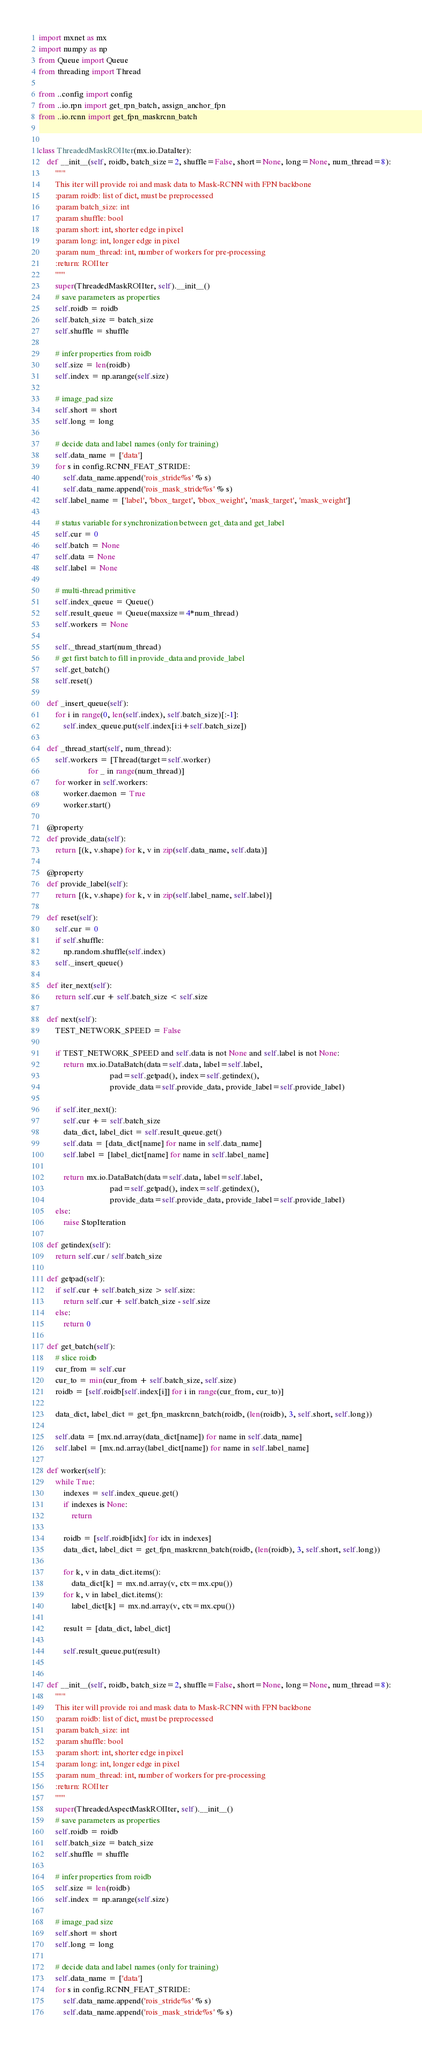Convert code to text. <code><loc_0><loc_0><loc_500><loc_500><_Python_>import mxnet as mx
import numpy as np
from Queue import Queue
from threading import Thread

from ..config import config
from ..io.rpn import get_rpn_batch, assign_anchor_fpn
from ..io.rcnn import get_fpn_maskrcnn_batch


class ThreadedMaskROIIter(mx.io.DataIter):
    def __init__(self, roidb, batch_size=2, shuffle=False, short=None, long=None, num_thread=8):
        """
        This iter will provide roi and mask data to Mask-RCNN with FPN backbone
        :param roidb: list of dict, must be preprocessed
        :param batch_size: int
        :param shuffle: bool
        :param short: int, shorter edge in pixel
        :param long: int, longer edge in pixel
        :param num_thread: int, number of workers for pre-processing
        :return: ROIIter
        """
        super(ThreadedMaskROIIter, self).__init__()
        # save parameters as properties
        self.roidb = roidb
        self.batch_size = batch_size
        self.shuffle = shuffle

        # infer properties from roidb
        self.size = len(roidb)
        self.index = np.arange(self.size)

        # image_pad size
        self.short = short
        self.long = long

        # decide data and label names (only for training)
        self.data_name = ['data']
        for s in config.RCNN_FEAT_STRIDE:
            self.data_name.append('rois_stride%s' % s)
            self.data_name.append('rois_mask_stride%s' % s)
        self.label_name = ['label', 'bbox_target', 'bbox_weight', 'mask_target', 'mask_weight']

        # status variable for synchronization between get_data and get_label
        self.cur = 0
        self.batch = None
        self.data = None
        self.label = None

        # multi-thread primitive
        self.index_queue = Queue()
        self.result_queue = Queue(maxsize=4*num_thread)
        self.workers = None

        self._thread_start(num_thread)
        # get first batch to fill in provide_data and provide_label
        self.get_batch()
        self.reset()

    def _insert_queue(self):
        for i in range(0, len(self.index), self.batch_size)[:-1]:
            self.index_queue.put(self.index[i:i+self.batch_size])

    def _thread_start(self, num_thread):
        self.workers = [Thread(target=self.worker)
                        for _ in range(num_thread)]
        for worker in self.workers:
            worker.daemon = True
            worker.start()

    @property
    def provide_data(self):
        return [(k, v.shape) for k, v in zip(self.data_name, self.data)]

    @property
    def provide_label(self):
        return [(k, v.shape) for k, v in zip(self.label_name, self.label)]

    def reset(self):
        self.cur = 0
        if self.shuffle:
            np.random.shuffle(self.index)
        self._insert_queue()

    def iter_next(self):
        return self.cur + self.batch_size < self.size

    def next(self):
        TEST_NETWORK_SPEED = False

        if TEST_NETWORK_SPEED and self.data is not None and self.label is not None:
            return mx.io.DataBatch(data=self.data, label=self.label,
                                   pad=self.getpad(), index=self.getindex(),
                                   provide_data=self.provide_data, provide_label=self.provide_label)

        if self.iter_next():
            self.cur += self.batch_size
            data_dict, label_dict = self.result_queue.get()
            self.data = [data_dict[name] for name in self.data_name]
            self.label = [label_dict[name] for name in self.label_name]

            return mx.io.DataBatch(data=self.data, label=self.label,
                                   pad=self.getpad(), index=self.getindex(),
                                   provide_data=self.provide_data, provide_label=self.provide_label)
        else:
            raise StopIteration

    def getindex(self):
        return self.cur / self.batch_size

    def getpad(self):
        if self.cur + self.batch_size > self.size:
            return self.cur + self.batch_size - self.size
        else:
            return 0

    def get_batch(self):
        # slice roidb
        cur_from = self.cur
        cur_to = min(cur_from + self.batch_size, self.size)
        roidb = [self.roidb[self.index[i]] for i in range(cur_from, cur_to)]

        data_dict, label_dict = get_fpn_maskrcnn_batch(roidb, (len(roidb), 3, self.short, self.long))

        self.data = [mx.nd.array(data_dict[name]) for name in self.data_name]
        self.label = [mx.nd.array(label_dict[name]) for name in self.label_name]

    def worker(self):
        while True:
            indexes = self.index_queue.get()
            if indexes is None:
                return

            roidb = [self.roidb[idx] for idx in indexes]
            data_dict, label_dict = get_fpn_maskrcnn_batch(roidb, (len(roidb), 3, self.short, self.long))

            for k, v in data_dict.items():
                data_dict[k] = mx.nd.array(v, ctx=mx.cpu())
            for k, v in label_dict.items():
                label_dict[k] = mx.nd.array(v, ctx=mx.cpu())

            result = [data_dict, label_dict]

            self.result_queue.put(result)


    def __init__(self, roidb, batch_size=2, shuffle=False, short=None, long=None, num_thread=8):
        """
        This iter will provide roi and mask data to Mask-RCNN with FPN backbone
        :param roidb: list of dict, must be preprocessed
        :param batch_size: int
        :param shuffle: bool
        :param short: int, shorter edge in pixel
        :param long: int, longer edge in pixel
        :param num_thread: int, number of workers for pre-processing
        :return: ROIIter
        """
        super(ThreadedAspectMaskROIIter, self).__init__()
        # save parameters as properties
        self.roidb = roidb
        self.batch_size = batch_size
        self.shuffle = shuffle

        # infer properties from roidb
        self.size = len(roidb)
        self.index = np.arange(self.size)

        # image_pad size
        self.short = short
        self.long = long

        # decide data and label names (only for training)
        self.data_name = ['data']
        for s in config.RCNN_FEAT_STRIDE:
            self.data_name.append('rois_stride%s' % s)
            self.data_name.append('rois_mask_stride%s' % s)</code> 